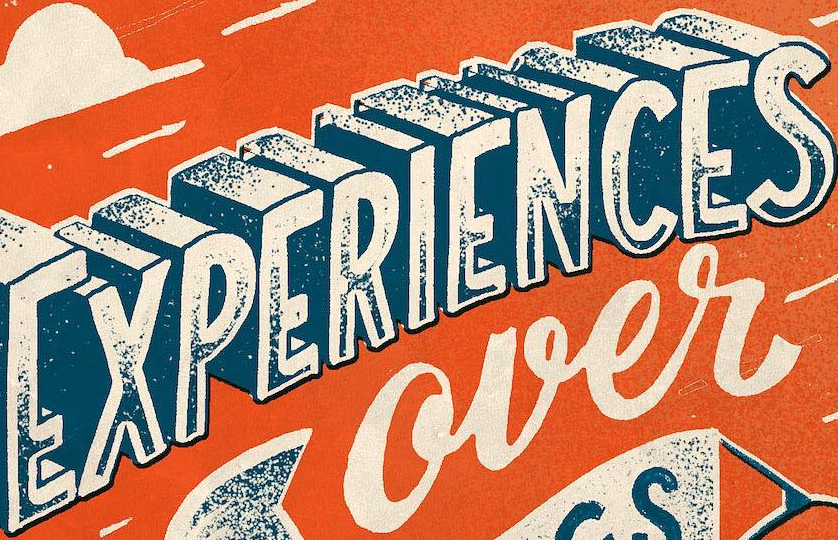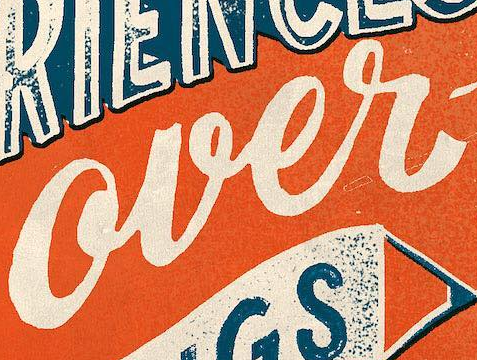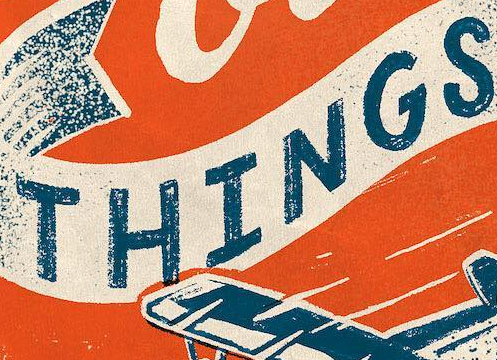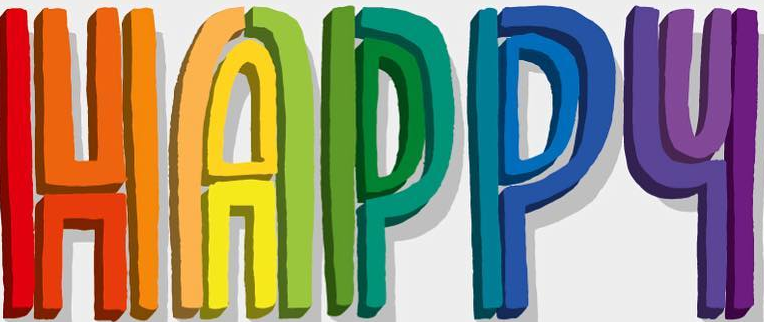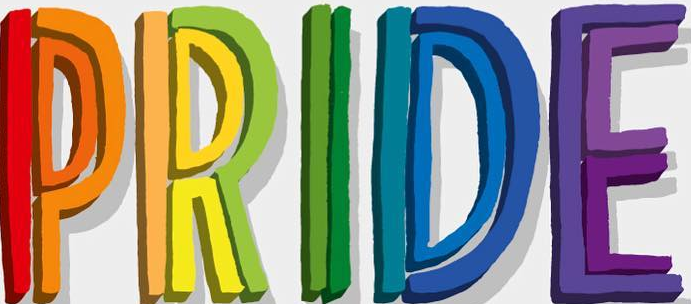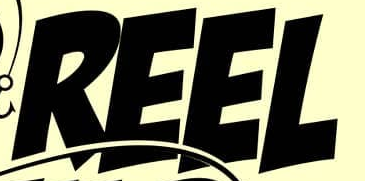Read the text from these images in sequence, separated by a semicolon. EXPERIENCES; over; THINGS; HAPPY; PRIDE; REEL 